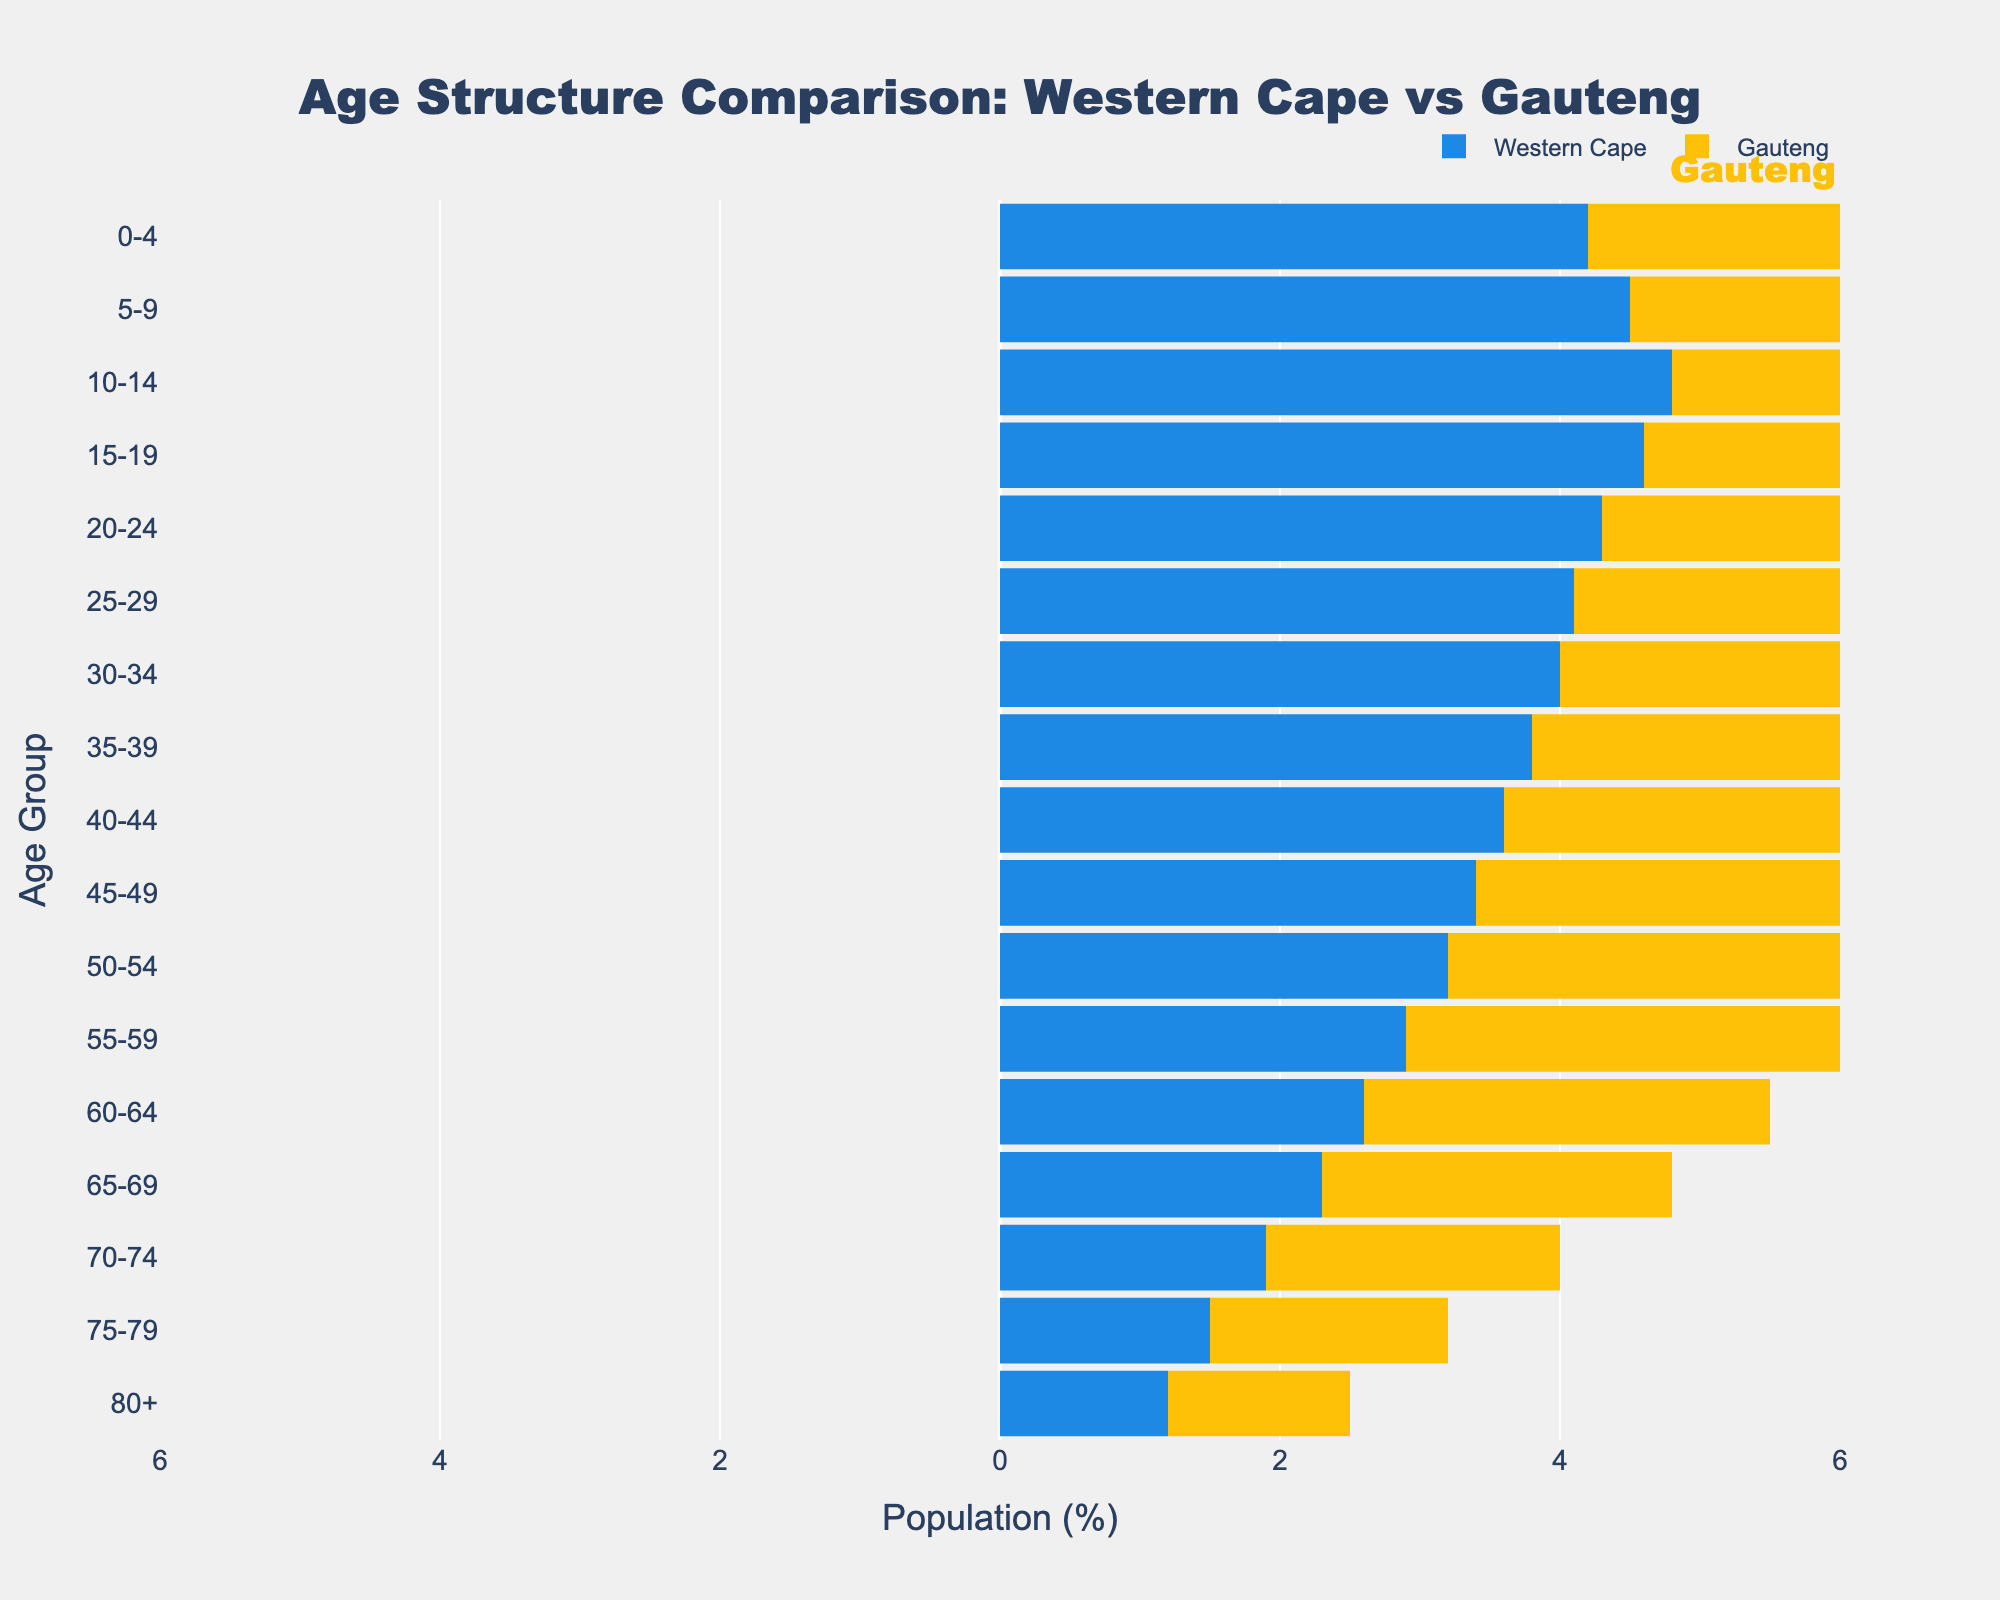What is the title of the figure? The title is located at the top of the figure and provides a summary of the content being illustrated. Here, the title reads "Age Structure Comparison: Western Cape vs Gauteng."
Answer: Age Structure Comparison: Western Cape vs Gauteng Which age group has the highest percentage in Gauteng? To find this, look at the bar lengths for Gauteng on the right side of the pyramid. The age group 10-14 has the longest bar, indicating the highest percentage.
Answer: 10-14 Are there more older people (65+) in the Western Cape or Gauteng? Compare the lengths of bars for age groups 65+ in both provinces. Gauteng's bars are slightly longer, indicating a higher percentage of older people.
Answer: Gauteng What is the percentage of 20-24-year-olds in Western Cape? Locate the bar corresponding to age group 20-24 on the left side of the pyramid, representing Western Cape. The bar reaches -4.3%.
Answer: 4.3% How does the population percentage of the 25-29 age group compare between Western Cape and Gauteng? Compare the lengths of the bars for the 25-29 age group on both sides. Western Cape's bar is -4.1%, and Gauteng's bar is 4.5%. Gauteng's population percentage is higher.
Answer: Gauteng's is higher Which province has a higher percentage of children aged 0-4? Compare the bars for the age group 0-4 on both sides of the pyramid. Gauteng's bar is longer, indicating a higher percentage.
Answer: Gauteng What is the average percentage of people aged 55-59 in both provinces? Sum the percentages for the age group 55-59 in both provinces and divide by 2: (2.9 + 3.2) / 2.
Answer: 3.05% Which age group has the smallest percentage difference between the two provinces? Compare the lengths of the bars for each age group and look for the smallest difference. The age group with the smallest difference is 60-64.
Answer: 60-64 Compare the overall population structure trends between Western Cape and Gauteng. Western Cape has a higher population percentage in younger age groups, while Gauteng shows a more evenly distributed population across all age groups, peaking at 5-9 and 10-14.
Answer: Western Cape is younger, Gauteng is more distributed What is the general trend in the proportion of the population as age increases in both provinces? Generally, both provinces show a decrease in population percentage as age increases, with younger age groups having higher population percentages.
Answer: Decreasing 